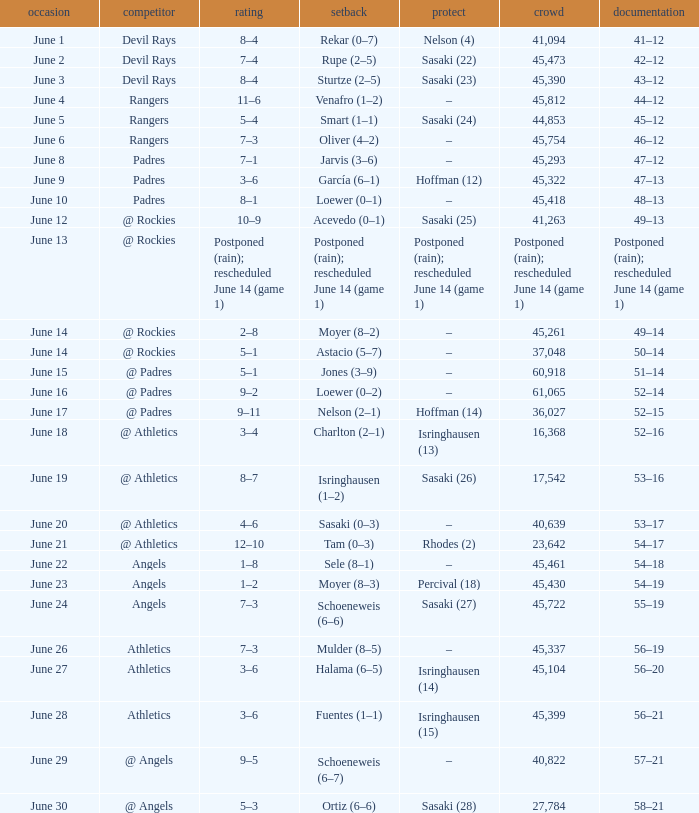What was the date of the Mariners game when they had a record of 53–17? June 20. 